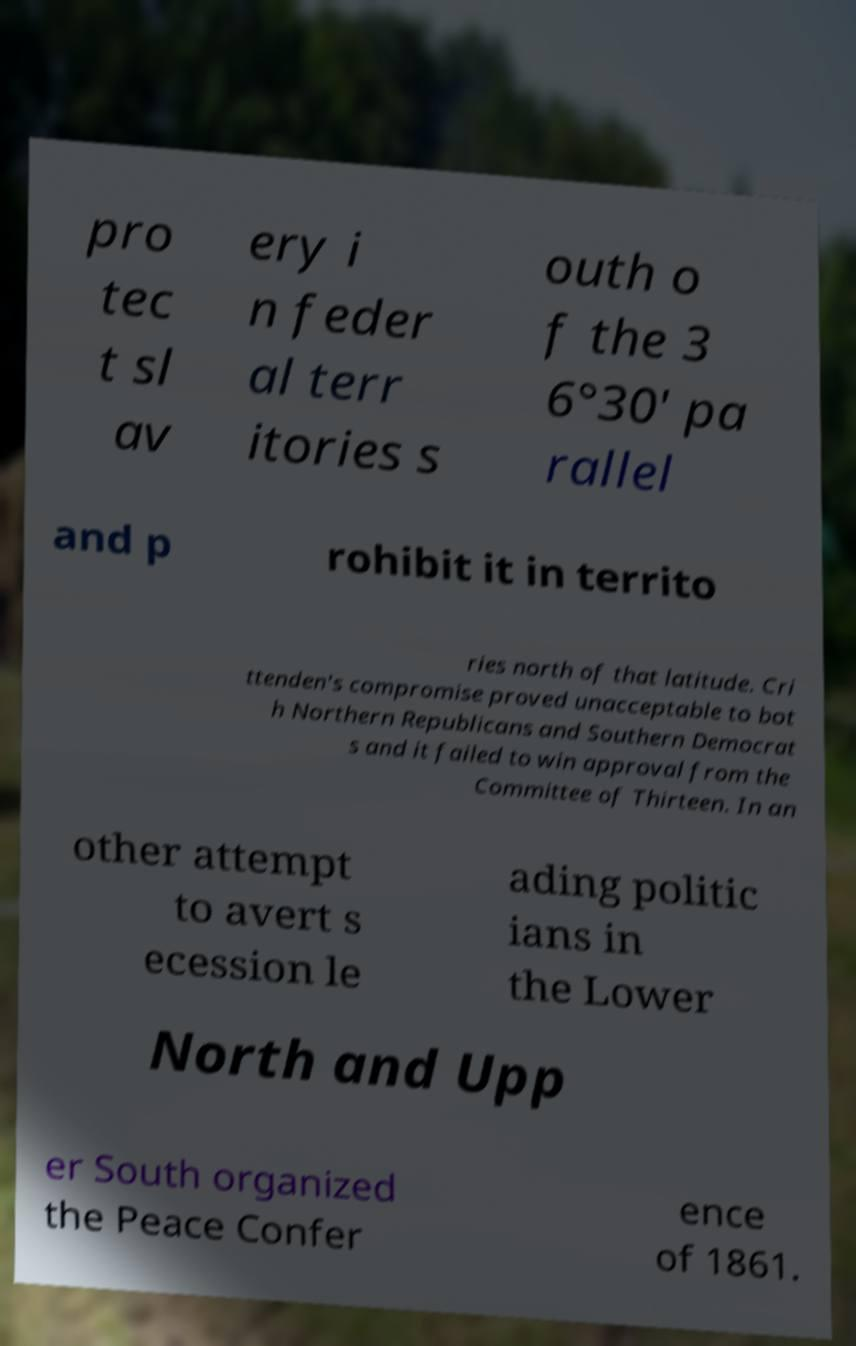Could you extract and type out the text from this image? pro tec t sl av ery i n feder al terr itories s outh o f the 3 6°30′ pa rallel and p rohibit it in territo ries north of that latitude. Cri ttenden's compromise proved unacceptable to bot h Northern Republicans and Southern Democrat s and it failed to win approval from the Committee of Thirteen. In an other attempt to avert s ecession le ading politic ians in the Lower North and Upp er South organized the Peace Confer ence of 1861. 